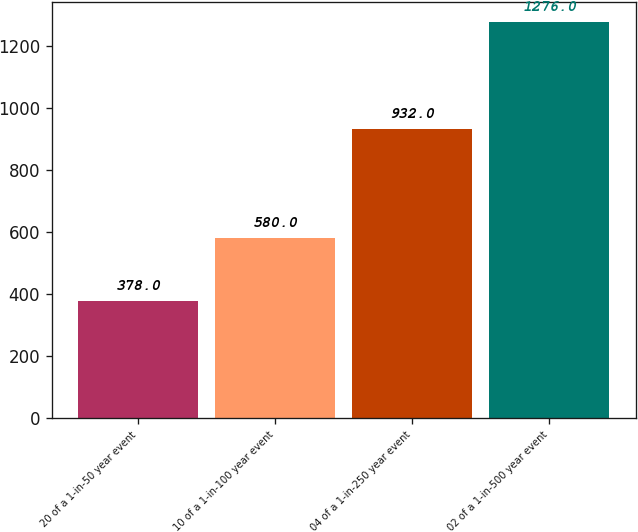<chart> <loc_0><loc_0><loc_500><loc_500><bar_chart><fcel>20 of a 1-in-50 year event<fcel>10 of a 1-in-100 year event<fcel>04 of a 1-in-250 year event<fcel>02 of a 1-in-500 year event<nl><fcel>378<fcel>580<fcel>932<fcel>1276<nl></chart> 